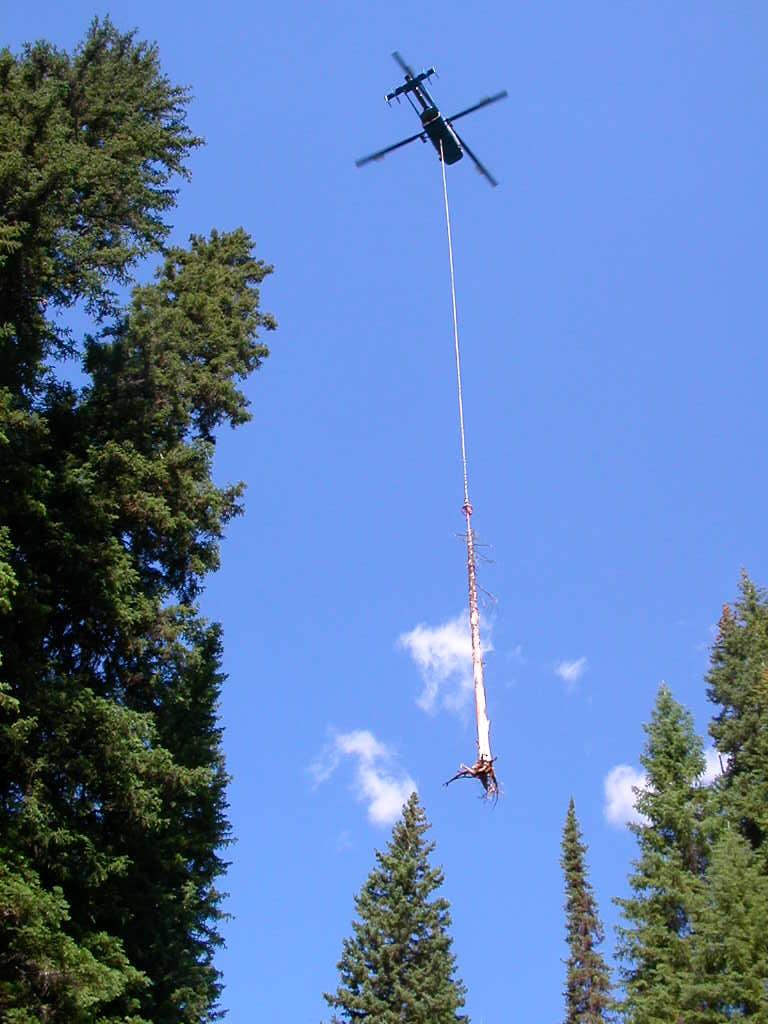What type of vegetation can be seen in the image? There are trees in the image. What is flying in the image? There is a helicopter flying in the image. What is the helicopter carrying? A trunk appears to be hung from the helicopter. What is visible in the background of the image? The sky is visible in the image. What can be observed in the sky? There are clouds in the sky. What type of home can be seen in the image? There is no home present in the image; it features trees, a helicopter, and a trunk. What relation does the trunk have with the trees in the image? There is no direct relation between the trunk and the trees in the image, as the trunk is being carried by a helicopter. 